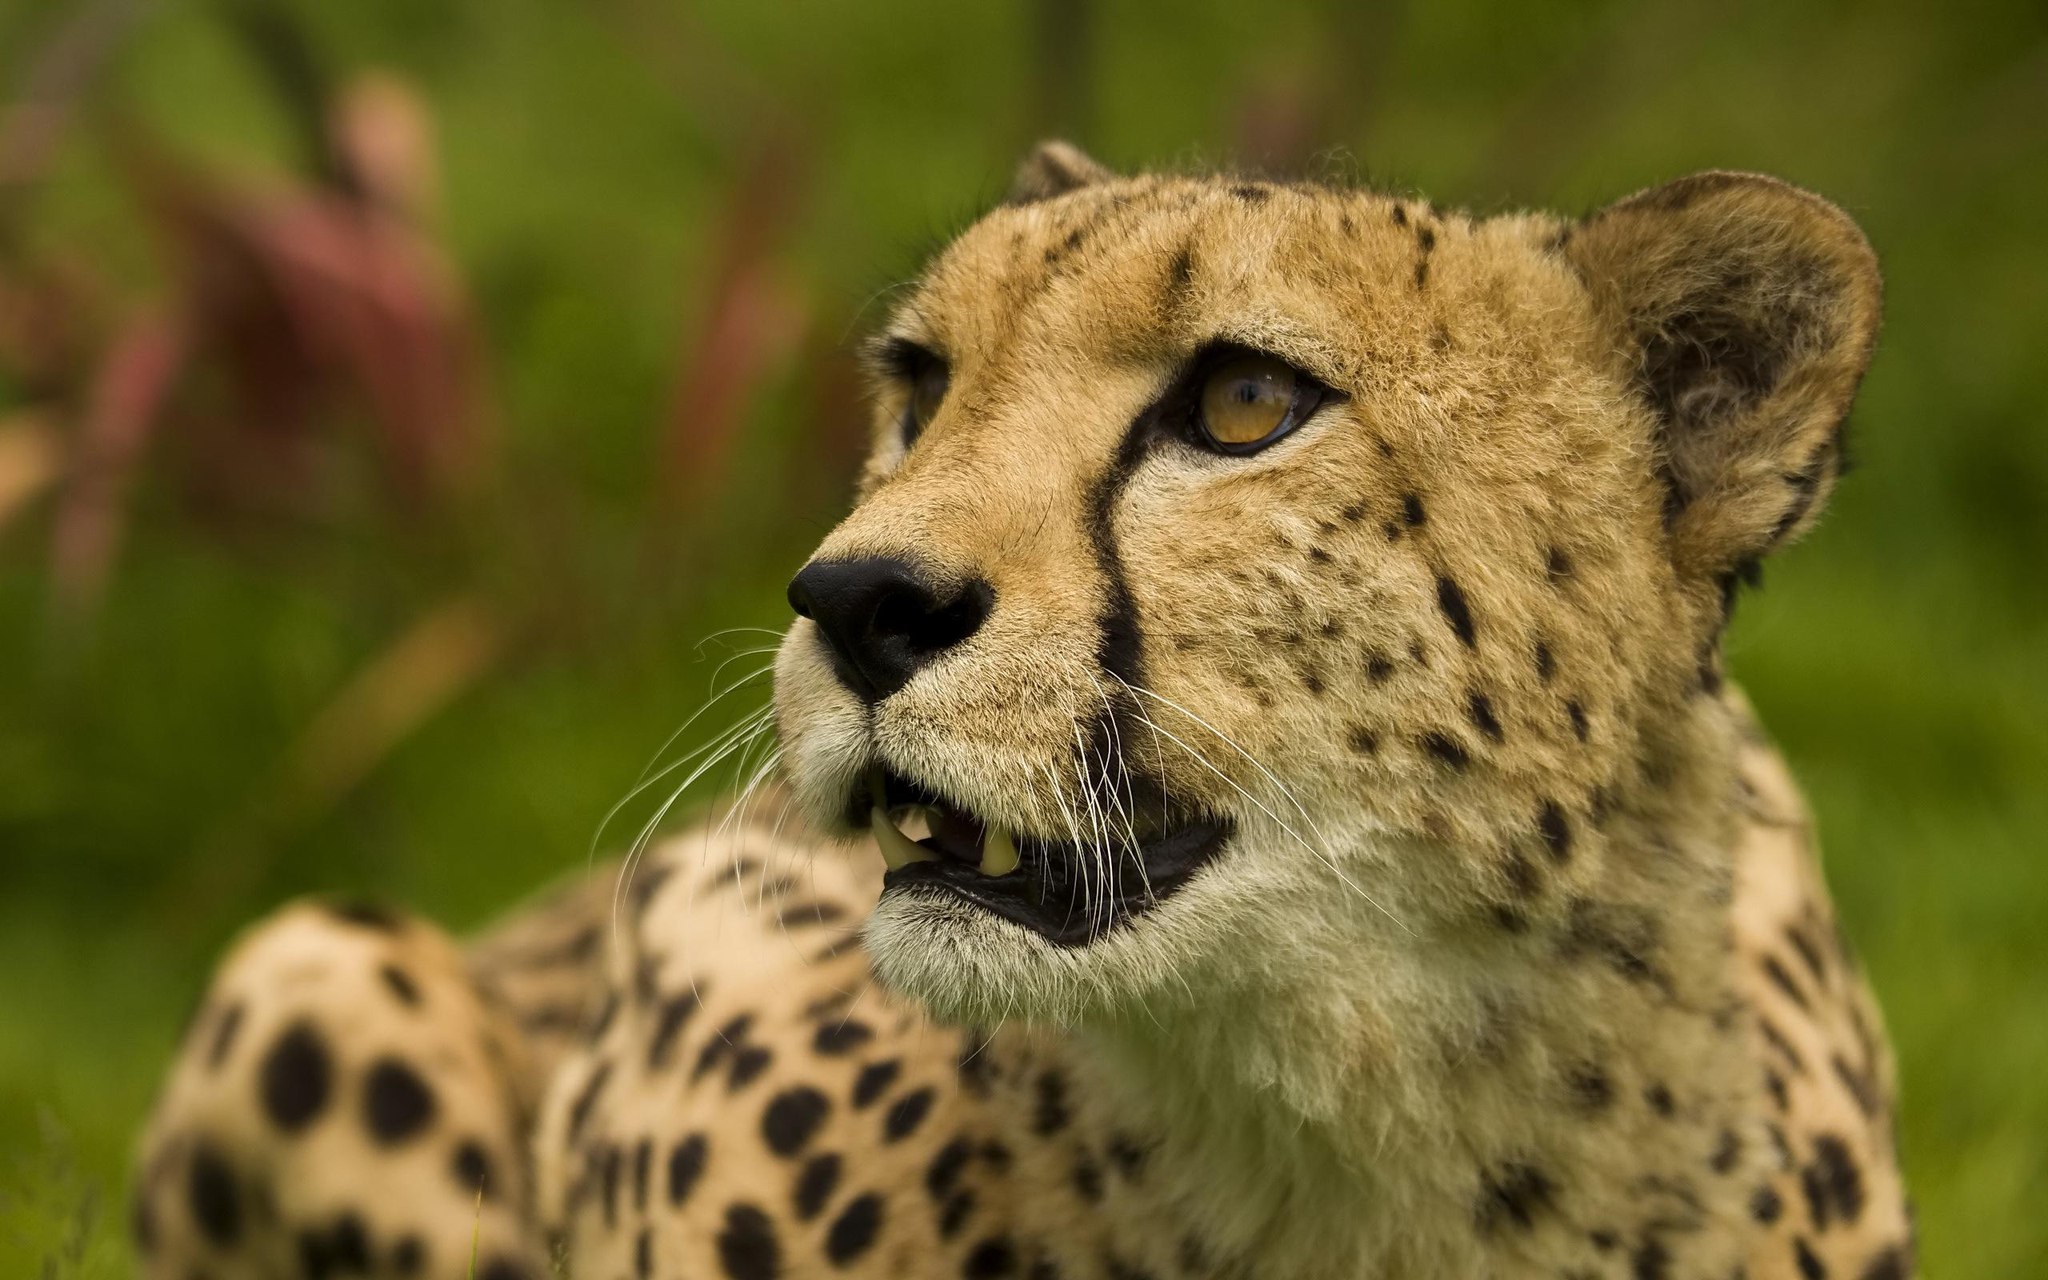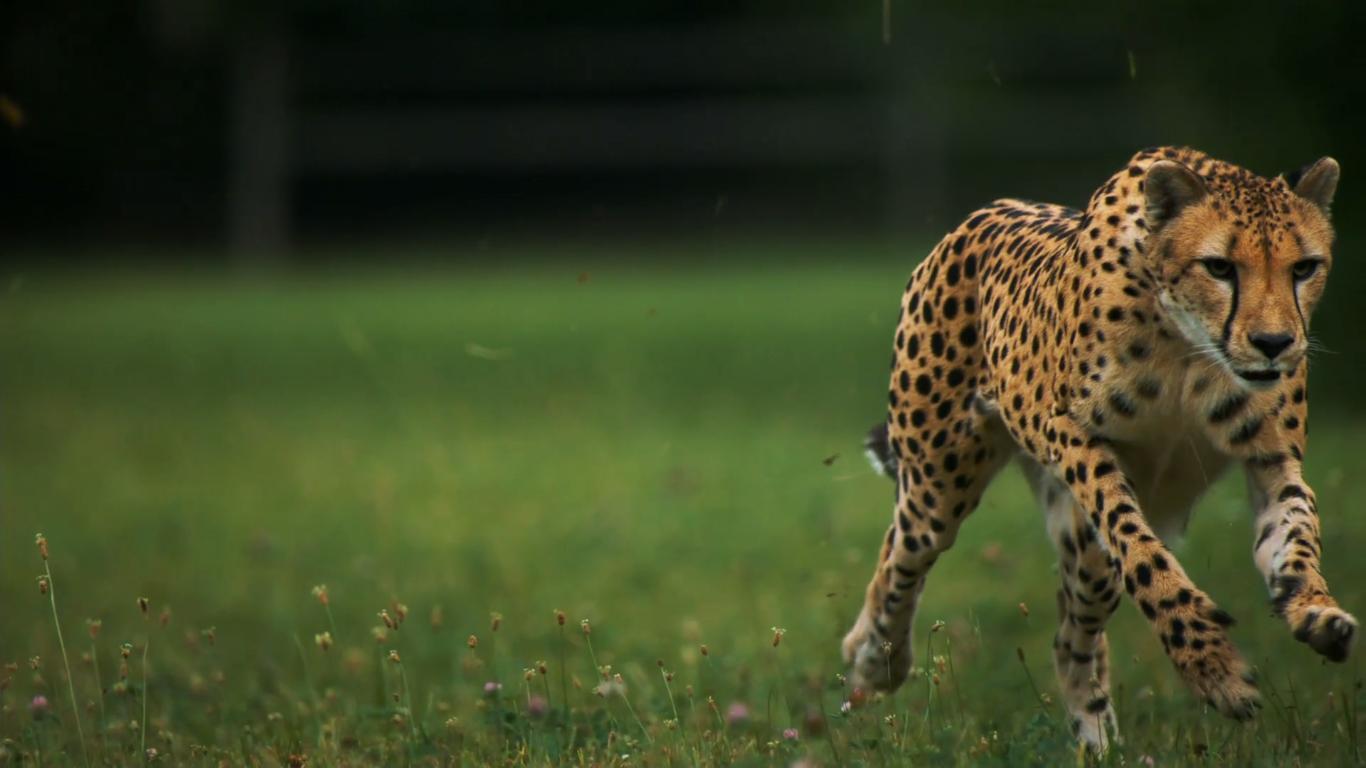The first image is the image on the left, the second image is the image on the right. Assess this claim about the two images: "A cheetah has its mouth partially open.". Correct or not? Answer yes or no. Yes. 